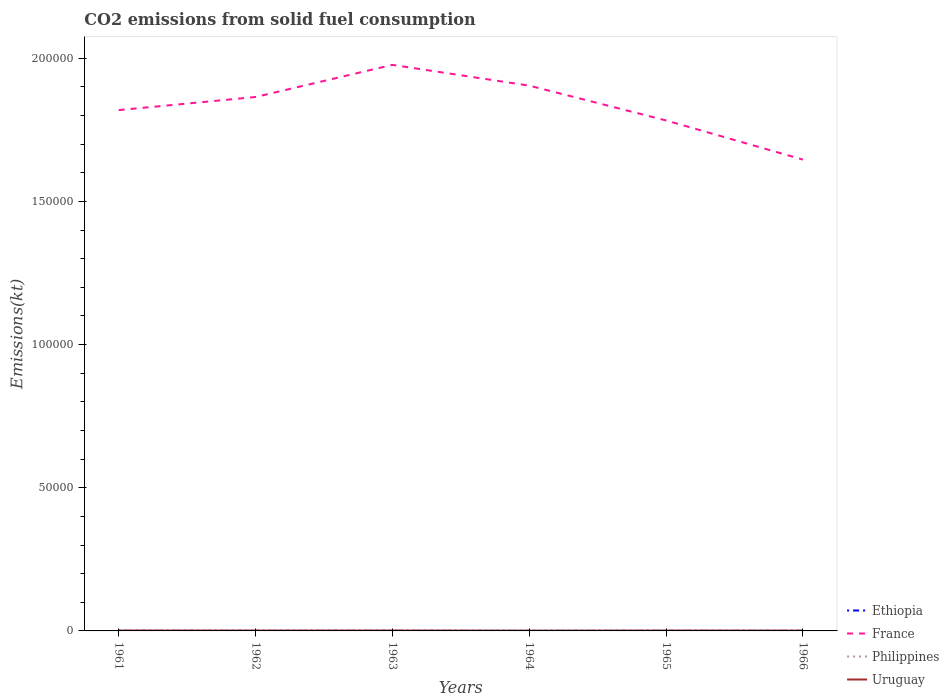How many different coloured lines are there?
Your answer should be compact. 4. Does the line corresponding to Philippines intersect with the line corresponding to France?
Your answer should be compact. No. Is the number of lines equal to the number of legend labels?
Provide a succinct answer. Yes. Across all years, what is the maximum amount of CO2 emitted in Uruguay?
Provide a succinct answer. 84.34. In which year was the amount of CO2 emitted in Ethiopia maximum?
Provide a succinct answer. 1964. What is the total amount of CO2 emitted in France in the graph?
Your answer should be compact. 1.22e+04. What is the difference between the highest and the second highest amount of CO2 emitted in France?
Offer a terse response. 3.31e+04. What is the difference between the highest and the lowest amount of CO2 emitted in Uruguay?
Make the answer very short. 4. Is the amount of CO2 emitted in Uruguay strictly greater than the amount of CO2 emitted in Ethiopia over the years?
Offer a terse response. No. How many years are there in the graph?
Offer a very short reply. 6. What is the difference between two consecutive major ticks on the Y-axis?
Offer a very short reply. 5.00e+04. Are the values on the major ticks of Y-axis written in scientific E-notation?
Offer a very short reply. No. Where does the legend appear in the graph?
Keep it short and to the point. Bottom right. How are the legend labels stacked?
Offer a very short reply. Vertical. What is the title of the graph?
Offer a terse response. CO2 emissions from solid fuel consumption. What is the label or title of the Y-axis?
Ensure brevity in your answer.  Emissions(kt). What is the Emissions(kt) of Ethiopia in 1961?
Give a very brief answer. 25.67. What is the Emissions(kt) of France in 1961?
Keep it short and to the point. 1.82e+05. What is the Emissions(kt) in Philippines in 1961?
Give a very brief answer. 179.68. What is the Emissions(kt) in Uruguay in 1961?
Provide a succinct answer. 124.68. What is the Emissions(kt) in Ethiopia in 1962?
Make the answer very short. 22. What is the Emissions(kt) of France in 1962?
Offer a terse response. 1.86e+05. What is the Emissions(kt) in Philippines in 1962?
Ensure brevity in your answer.  212.69. What is the Emissions(kt) of Uruguay in 1962?
Your answer should be very brief. 110.01. What is the Emissions(kt) of Ethiopia in 1963?
Your answer should be compact. 25.67. What is the Emissions(kt) in France in 1963?
Keep it short and to the point. 1.98e+05. What is the Emissions(kt) of Philippines in 1963?
Ensure brevity in your answer.  201.69. What is the Emissions(kt) in Uruguay in 1963?
Provide a short and direct response. 117.34. What is the Emissions(kt) in Ethiopia in 1964?
Keep it short and to the point. 3.67. What is the Emissions(kt) of France in 1964?
Make the answer very short. 1.90e+05. What is the Emissions(kt) of Philippines in 1964?
Give a very brief answer. 150.35. What is the Emissions(kt) of Uruguay in 1964?
Offer a terse response. 84.34. What is the Emissions(kt) of Ethiopia in 1965?
Provide a succinct answer. 25.67. What is the Emissions(kt) of France in 1965?
Give a very brief answer. 1.78e+05. What is the Emissions(kt) of Philippines in 1965?
Make the answer very short. 150.35. What is the Emissions(kt) in Uruguay in 1965?
Give a very brief answer. 110.01. What is the Emissions(kt) of Ethiopia in 1966?
Offer a very short reply. 25.67. What is the Emissions(kt) in France in 1966?
Your response must be concise. 1.65e+05. What is the Emissions(kt) of Philippines in 1966?
Keep it short and to the point. 135.68. What is the Emissions(kt) in Uruguay in 1966?
Your answer should be compact. 99.01. Across all years, what is the maximum Emissions(kt) of Ethiopia?
Your response must be concise. 25.67. Across all years, what is the maximum Emissions(kt) in France?
Keep it short and to the point. 1.98e+05. Across all years, what is the maximum Emissions(kt) of Philippines?
Keep it short and to the point. 212.69. Across all years, what is the maximum Emissions(kt) in Uruguay?
Offer a very short reply. 124.68. Across all years, what is the minimum Emissions(kt) of Ethiopia?
Your response must be concise. 3.67. Across all years, what is the minimum Emissions(kt) of France?
Provide a short and direct response. 1.65e+05. Across all years, what is the minimum Emissions(kt) in Philippines?
Offer a terse response. 135.68. Across all years, what is the minimum Emissions(kt) in Uruguay?
Provide a succinct answer. 84.34. What is the total Emissions(kt) of Ethiopia in the graph?
Provide a short and direct response. 128.34. What is the total Emissions(kt) of France in the graph?
Provide a succinct answer. 1.10e+06. What is the total Emissions(kt) of Philippines in the graph?
Give a very brief answer. 1030.43. What is the total Emissions(kt) in Uruguay in the graph?
Ensure brevity in your answer.  645.39. What is the difference between the Emissions(kt) in Ethiopia in 1961 and that in 1962?
Provide a succinct answer. 3.67. What is the difference between the Emissions(kt) in France in 1961 and that in 1962?
Offer a very short reply. -4583.75. What is the difference between the Emissions(kt) in Philippines in 1961 and that in 1962?
Your response must be concise. -33. What is the difference between the Emissions(kt) in Uruguay in 1961 and that in 1962?
Offer a terse response. 14.67. What is the difference between the Emissions(kt) in France in 1961 and that in 1963?
Offer a terse response. -1.58e+04. What is the difference between the Emissions(kt) of Philippines in 1961 and that in 1963?
Make the answer very short. -22. What is the difference between the Emissions(kt) of Uruguay in 1961 and that in 1963?
Your response must be concise. 7.33. What is the difference between the Emissions(kt) of Ethiopia in 1961 and that in 1964?
Offer a terse response. 22. What is the difference between the Emissions(kt) of France in 1961 and that in 1964?
Keep it short and to the point. -8551.44. What is the difference between the Emissions(kt) in Philippines in 1961 and that in 1964?
Provide a short and direct response. 29.34. What is the difference between the Emissions(kt) in Uruguay in 1961 and that in 1964?
Provide a succinct answer. 40.34. What is the difference between the Emissions(kt) of France in 1961 and that in 1965?
Keep it short and to the point. 3600.99. What is the difference between the Emissions(kt) in Philippines in 1961 and that in 1965?
Keep it short and to the point. 29.34. What is the difference between the Emissions(kt) in Uruguay in 1961 and that in 1965?
Offer a terse response. 14.67. What is the difference between the Emissions(kt) in Ethiopia in 1961 and that in 1966?
Your response must be concise. 0. What is the difference between the Emissions(kt) of France in 1961 and that in 1966?
Offer a terse response. 1.73e+04. What is the difference between the Emissions(kt) of Philippines in 1961 and that in 1966?
Keep it short and to the point. 44. What is the difference between the Emissions(kt) of Uruguay in 1961 and that in 1966?
Ensure brevity in your answer.  25.67. What is the difference between the Emissions(kt) in Ethiopia in 1962 and that in 1963?
Offer a terse response. -3.67. What is the difference between the Emissions(kt) of France in 1962 and that in 1963?
Offer a terse response. -1.12e+04. What is the difference between the Emissions(kt) in Philippines in 1962 and that in 1963?
Keep it short and to the point. 11. What is the difference between the Emissions(kt) of Uruguay in 1962 and that in 1963?
Keep it short and to the point. -7.33. What is the difference between the Emissions(kt) of Ethiopia in 1962 and that in 1964?
Keep it short and to the point. 18.34. What is the difference between the Emissions(kt) of France in 1962 and that in 1964?
Make the answer very short. -3967.69. What is the difference between the Emissions(kt) of Philippines in 1962 and that in 1964?
Provide a short and direct response. 62.34. What is the difference between the Emissions(kt) in Uruguay in 1962 and that in 1964?
Offer a terse response. 25.67. What is the difference between the Emissions(kt) of Ethiopia in 1962 and that in 1965?
Keep it short and to the point. -3.67. What is the difference between the Emissions(kt) in France in 1962 and that in 1965?
Give a very brief answer. 8184.74. What is the difference between the Emissions(kt) of Philippines in 1962 and that in 1965?
Keep it short and to the point. 62.34. What is the difference between the Emissions(kt) in Uruguay in 1962 and that in 1965?
Keep it short and to the point. 0. What is the difference between the Emissions(kt) in Ethiopia in 1962 and that in 1966?
Offer a very short reply. -3.67. What is the difference between the Emissions(kt) of France in 1962 and that in 1966?
Your answer should be compact. 2.19e+04. What is the difference between the Emissions(kt) of Philippines in 1962 and that in 1966?
Keep it short and to the point. 77.01. What is the difference between the Emissions(kt) of Uruguay in 1962 and that in 1966?
Your answer should be very brief. 11. What is the difference between the Emissions(kt) of Ethiopia in 1963 and that in 1964?
Your answer should be compact. 22. What is the difference between the Emissions(kt) in France in 1963 and that in 1964?
Offer a very short reply. 7249.66. What is the difference between the Emissions(kt) in Philippines in 1963 and that in 1964?
Ensure brevity in your answer.  51.34. What is the difference between the Emissions(kt) of Uruguay in 1963 and that in 1964?
Keep it short and to the point. 33. What is the difference between the Emissions(kt) in France in 1963 and that in 1965?
Your answer should be very brief. 1.94e+04. What is the difference between the Emissions(kt) in Philippines in 1963 and that in 1965?
Your answer should be very brief. 51.34. What is the difference between the Emissions(kt) in Uruguay in 1963 and that in 1965?
Your answer should be compact. 7.33. What is the difference between the Emissions(kt) in France in 1963 and that in 1966?
Provide a short and direct response. 3.31e+04. What is the difference between the Emissions(kt) of Philippines in 1963 and that in 1966?
Provide a succinct answer. 66.01. What is the difference between the Emissions(kt) of Uruguay in 1963 and that in 1966?
Provide a short and direct response. 18.34. What is the difference between the Emissions(kt) of Ethiopia in 1964 and that in 1965?
Offer a terse response. -22. What is the difference between the Emissions(kt) in France in 1964 and that in 1965?
Give a very brief answer. 1.22e+04. What is the difference between the Emissions(kt) of Philippines in 1964 and that in 1965?
Give a very brief answer. 0. What is the difference between the Emissions(kt) in Uruguay in 1964 and that in 1965?
Your answer should be very brief. -25.67. What is the difference between the Emissions(kt) in Ethiopia in 1964 and that in 1966?
Ensure brevity in your answer.  -22. What is the difference between the Emissions(kt) in France in 1964 and that in 1966?
Make the answer very short. 2.58e+04. What is the difference between the Emissions(kt) of Philippines in 1964 and that in 1966?
Provide a succinct answer. 14.67. What is the difference between the Emissions(kt) in Uruguay in 1964 and that in 1966?
Offer a very short reply. -14.67. What is the difference between the Emissions(kt) in Ethiopia in 1965 and that in 1966?
Offer a terse response. 0. What is the difference between the Emissions(kt) in France in 1965 and that in 1966?
Make the answer very short. 1.37e+04. What is the difference between the Emissions(kt) of Philippines in 1965 and that in 1966?
Your response must be concise. 14.67. What is the difference between the Emissions(kt) of Uruguay in 1965 and that in 1966?
Offer a terse response. 11. What is the difference between the Emissions(kt) in Ethiopia in 1961 and the Emissions(kt) in France in 1962?
Provide a short and direct response. -1.86e+05. What is the difference between the Emissions(kt) of Ethiopia in 1961 and the Emissions(kt) of Philippines in 1962?
Give a very brief answer. -187.02. What is the difference between the Emissions(kt) of Ethiopia in 1961 and the Emissions(kt) of Uruguay in 1962?
Provide a short and direct response. -84.34. What is the difference between the Emissions(kt) in France in 1961 and the Emissions(kt) in Philippines in 1962?
Ensure brevity in your answer.  1.82e+05. What is the difference between the Emissions(kt) of France in 1961 and the Emissions(kt) of Uruguay in 1962?
Keep it short and to the point. 1.82e+05. What is the difference between the Emissions(kt) in Philippines in 1961 and the Emissions(kt) in Uruguay in 1962?
Offer a terse response. 69.67. What is the difference between the Emissions(kt) in Ethiopia in 1961 and the Emissions(kt) in France in 1963?
Make the answer very short. -1.98e+05. What is the difference between the Emissions(kt) of Ethiopia in 1961 and the Emissions(kt) of Philippines in 1963?
Offer a terse response. -176.02. What is the difference between the Emissions(kt) in Ethiopia in 1961 and the Emissions(kt) in Uruguay in 1963?
Offer a very short reply. -91.67. What is the difference between the Emissions(kt) in France in 1961 and the Emissions(kt) in Philippines in 1963?
Keep it short and to the point. 1.82e+05. What is the difference between the Emissions(kt) of France in 1961 and the Emissions(kt) of Uruguay in 1963?
Ensure brevity in your answer.  1.82e+05. What is the difference between the Emissions(kt) of Philippines in 1961 and the Emissions(kt) of Uruguay in 1963?
Offer a terse response. 62.34. What is the difference between the Emissions(kt) in Ethiopia in 1961 and the Emissions(kt) in France in 1964?
Give a very brief answer. -1.90e+05. What is the difference between the Emissions(kt) of Ethiopia in 1961 and the Emissions(kt) of Philippines in 1964?
Your answer should be compact. -124.68. What is the difference between the Emissions(kt) in Ethiopia in 1961 and the Emissions(kt) in Uruguay in 1964?
Give a very brief answer. -58.67. What is the difference between the Emissions(kt) of France in 1961 and the Emissions(kt) of Philippines in 1964?
Offer a terse response. 1.82e+05. What is the difference between the Emissions(kt) in France in 1961 and the Emissions(kt) in Uruguay in 1964?
Make the answer very short. 1.82e+05. What is the difference between the Emissions(kt) in Philippines in 1961 and the Emissions(kt) in Uruguay in 1964?
Your response must be concise. 95.34. What is the difference between the Emissions(kt) in Ethiopia in 1961 and the Emissions(kt) in France in 1965?
Offer a very short reply. -1.78e+05. What is the difference between the Emissions(kt) of Ethiopia in 1961 and the Emissions(kt) of Philippines in 1965?
Offer a very short reply. -124.68. What is the difference between the Emissions(kt) of Ethiopia in 1961 and the Emissions(kt) of Uruguay in 1965?
Your answer should be very brief. -84.34. What is the difference between the Emissions(kt) of France in 1961 and the Emissions(kt) of Philippines in 1965?
Your answer should be very brief. 1.82e+05. What is the difference between the Emissions(kt) in France in 1961 and the Emissions(kt) in Uruguay in 1965?
Your answer should be compact. 1.82e+05. What is the difference between the Emissions(kt) in Philippines in 1961 and the Emissions(kt) in Uruguay in 1965?
Offer a very short reply. 69.67. What is the difference between the Emissions(kt) in Ethiopia in 1961 and the Emissions(kt) in France in 1966?
Provide a short and direct response. -1.65e+05. What is the difference between the Emissions(kt) of Ethiopia in 1961 and the Emissions(kt) of Philippines in 1966?
Keep it short and to the point. -110.01. What is the difference between the Emissions(kt) of Ethiopia in 1961 and the Emissions(kt) of Uruguay in 1966?
Your response must be concise. -73.34. What is the difference between the Emissions(kt) in France in 1961 and the Emissions(kt) in Philippines in 1966?
Keep it short and to the point. 1.82e+05. What is the difference between the Emissions(kt) in France in 1961 and the Emissions(kt) in Uruguay in 1966?
Provide a short and direct response. 1.82e+05. What is the difference between the Emissions(kt) of Philippines in 1961 and the Emissions(kt) of Uruguay in 1966?
Ensure brevity in your answer.  80.67. What is the difference between the Emissions(kt) of Ethiopia in 1962 and the Emissions(kt) of France in 1963?
Provide a short and direct response. -1.98e+05. What is the difference between the Emissions(kt) in Ethiopia in 1962 and the Emissions(kt) in Philippines in 1963?
Offer a terse response. -179.68. What is the difference between the Emissions(kt) of Ethiopia in 1962 and the Emissions(kt) of Uruguay in 1963?
Give a very brief answer. -95.34. What is the difference between the Emissions(kt) in France in 1962 and the Emissions(kt) in Philippines in 1963?
Provide a short and direct response. 1.86e+05. What is the difference between the Emissions(kt) of France in 1962 and the Emissions(kt) of Uruguay in 1963?
Your answer should be compact. 1.86e+05. What is the difference between the Emissions(kt) of Philippines in 1962 and the Emissions(kt) of Uruguay in 1963?
Offer a terse response. 95.34. What is the difference between the Emissions(kt) in Ethiopia in 1962 and the Emissions(kt) in France in 1964?
Make the answer very short. -1.90e+05. What is the difference between the Emissions(kt) in Ethiopia in 1962 and the Emissions(kt) in Philippines in 1964?
Keep it short and to the point. -128.34. What is the difference between the Emissions(kt) of Ethiopia in 1962 and the Emissions(kt) of Uruguay in 1964?
Offer a very short reply. -62.34. What is the difference between the Emissions(kt) of France in 1962 and the Emissions(kt) of Philippines in 1964?
Offer a very short reply. 1.86e+05. What is the difference between the Emissions(kt) in France in 1962 and the Emissions(kt) in Uruguay in 1964?
Provide a succinct answer. 1.86e+05. What is the difference between the Emissions(kt) in Philippines in 1962 and the Emissions(kt) in Uruguay in 1964?
Offer a very short reply. 128.34. What is the difference between the Emissions(kt) in Ethiopia in 1962 and the Emissions(kt) in France in 1965?
Your response must be concise. -1.78e+05. What is the difference between the Emissions(kt) of Ethiopia in 1962 and the Emissions(kt) of Philippines in 1965?
Your answer should be very brief. -128.34. What is the difference between the Emissions(kt) of Ethiopia in 1962 and the Emissions(kt) of Uruguay in 1965?
Provide a succinct answer. -88.01. What is the difference between the Emissions(kt) in France in 1962 and the Emissions(kt) in Philippines in 1965?
Keep it short and to the point. 1.86e+05. What is the difference between the Emissions(kt) of France in 1962 and the Emissions(kt) of Uruguay in 1965?
Provide a succinct answer. 1.86e+05. What is the difference between the Emissions(kt) in Philippines in 1962 and the Emissions(kt) in Uruguay in 1965?
Offer a terse response. 102.68. What is the difference between the Emissions(kt) of Ethiopia in 1962 and the Emissions(kt) of France in 1966?
Your response must be concise. -1.65e+05. What is the difference between the Emissions(kt) of Ethiopia in 1962 and the Emissions(kt) of Philippines in 1966?
Offer a terse response. -113.68. What is the difference between the Emissions(kt) in Ethiopia in 1962 and the Emissions(kt) in Uruguay in 1966?
Offer a very short reply. -77.01. What is the difference between the Emissions(kt) of France in 1962 and the Emissions(kt) of Philippines in 1966?
Ensure brevity in your answer.  1.86e+05. What is the difference between the Emissions(kt) of France in 1962 and the Emissions(kt) of Uruguay in 1966?
Make the answer very short. 1.86e+05. What is the difference between the Emissions(kt) in Philippines in 1962 and the Emissions(kt) in Uruguay in 1966?
Provide a succinct answer. 113.68. What is the difference between the Emissions(kt) in Ethiopia in 1963 and the Emissions(kt) in France in 1964?
Your response must be concise. -1.90e+05. What is the difference between the Emissions(kt) of Ethiopia in 1963 and the Emissions(kt) of Philippines in 1964?
Give a very brief answer. -124.68. What is the difference between the Emissions(kt) in Ethiopia in 1963 and the Emissions(kt) in Uruguay in 1964?
Your answer should be compact. -58.67. What is the difference between the Emissions(kt) in France in 1963 and the Emissions(kt) in Philippines in 1964?
Ensure brevity in your answer.  1.98e+05. What is the difference between the Emissions(kt) of France in 1963 and the Emissions(kt) of Uruguay in 1964?
Offer a terse response. 1.98e+05. What is the difference between the Emissions(kt) of Philippines in 1963 and the Emissions(kt) of Uruguay in 1964?
Your answer should be compact. 117.34. What is the difference between the Emissions(kt) in Ethiopia in 1963 and the Emissions(kt) in France in 1965?
Your answer should be compact. -1.78e+05. What is the difference between the Emissions(kt) of Ethiopia in 1963 and the Emissions(kt) of Philippines in 1965?
Your response must be concise. -124.68. What is the difference between the Emissions(kt) of Ethiopia in 1963 and the Emissions(kt) of Uruguay in 1965?
Ensure brevity in your answer.  -84.34. What is the difference between the Emissions(kt) of France in 1963 and the Emissions(kt) of Philippines in 1965?
Provide a succinct answer. 1.98e+05. What is the difference between the Emissions(kt) of France in 1963 and the Emissions(kt) of Uruguay in 1965?
Make the answer very short. 1.98e+05. What is the difference between the Emissions(kt) in Philippines in 1963 and the Emissions(kt) in Uruguay in 1965?
Your answer should be compact. 91.67. What is the difference between the Emissions(kt) of Ethiopia in 1963 and the Emissions(kt) of France in 1966?
Your response must be concise. -1.65e+05. What is the difference between the Emissions(kt) in Ethiopia in 1963 and the Emissions(kt) in Philippines in 1966?
Make the answer very short. -110.01. What is the difference between the Emissions(kt) of Ethiopia in 1963 and the Emissions(kt) of Uruguay in 1966?
Make the answer very short. -73.34. What is the difference between the Emissions(kt) of France in 1963 and the Emissions(kt) of Philippines in 1966?
Give a very brief answer. 1.98e+05. What is the difference between the Emissions(kt) of France in 1963 and the Emissions(kt) of Uruguay in 1966?
Make the answer very short. 1.98e+05. What is the difference between the Emissions(kt) of Philippines in 1963 and the Emissions(kt) of Uruguay in 1966?
Make the answer very short. 102.68. What is the difference between the Emissions(kt) of Ethiopia in 1964 and the Emissions(kt) of France in 1965?
Your answer should be compact. -1.78e+05. What is the difference between the Emissions(kt) of Ethiopia in 1964 and the Emissions(kt) of Philippines in 1965?
Your response must be concise. -146.68. What is the difference between the Emissions(kt) of Ethiopia in 1964 and the Emissions(kt) of Uruguay in 1965?
Give a very brief answer. -106.34. What is the difference between the Emissions(kt) of France in 1964 and the Emissions(kt) of Philippines in 1965?
Provide a short and direct response. 1.90e+05. What is the difference between the Emissions(kt) of France in 1964 and the Emissions(kt) of Uruguay in 1965?
Provide a short and direct response. 1.90e+05. What is the difference between the Emissions(kt) in Philippines in 1964 and the Emissions(kt) in Uruguay in 1965?
Your answer should be compact. 40.34. What is the difference between the Emissions(kt) in Ethiopia in 1964 and the Emissions(kt) in France in 1966?
Make the answer very short. -1.65e+05. What is the difference between the Emissions(kt) of Ethiopia in 1964 and the Emissions(kt) of Philippines in 1966?
Give a very brief answer. -132.01. What is the difference between the Emissions(kt) of Ethiopia in 1964 and the Emissions(kt) of Uruguay in 1966?
Your answer should be very brief. -95.34. What is the difference between the Emissions(kt) of France in 1964 and the Emissions(kt) of Philippines in 1966?
Keep it short and to the point. 1.90e+05. What is the difference between the Emissions(kt) in France in 1964 and the Emissions(kt) in Uruguay in 1966?
Provide a succinct answer. 1.90e+05. What is the difference between the Emissions(kt) in Philippines in 1964 and the Emissions(kt) in Uruguay in 1966?
Your answer should be very brief. 51.34. What is the difference between the Emissions(kt) in Ethiopia in 1965 and the Emissions(kt) in France in 1966?
Provide a short and direct response. -1.65e+05. What is the difference between the Emissions(kt) of Ethiopia in 1965 and the Emissions(kt) of Philippines in 1966?
Offer a very short reply. -110.01. What is the difference between the Emissions(kt) of Ethiopia in 1965 and the Emissions(kt) of Uruguay in 1966?
Offer a very short reply. -73.34. What is the difference between the Emissions(kt) of France in 1965 and the Emissions(kt) of Philippines in 1966?
Offer a terse response. 1.78e+05. What is the difference between the Emissions(kt) of France in 1965 and the Emissions(kt) of Uruguay in 1966?
Your response must be concise. 1.78e+05. What is the difference between the Emissions(kt) of Philippines in 1965 and the Emissions(kt) of Uruguay in 1966?
Ensure brevity in your answer.  51.34. What is the average Emissions(kt) of Ethiopia per year?
Provide a short and direct response. 21.39. What is the average Emissions(kt) in France per year?
Give a very brief answer. 1.83e+05. What is the average Emissions(kt) in Philippines per year?
Your answer should be very brief. 171.74. What is the average Emissions(kt) of Uruguay per year?
Your answer should be very brief. 107.57. In the year 1961, what is the difference between the Emissions(kt) in Ethiopia and Emissions(kt) in France?
Keep it short and to the point. -1.82e+05. In the year 1961, what is the difference between the Emissions(kt) of Ethiopia and Emissions(kt) of Philippines?
Your answer should be compact. -154.01. In the year 1961, what is the difference between the Emissions(kt) in Ethiopia and Emissions(kt) in Uruguay?
Keep it short and to the point. -99.01. In the year 1961, what is the difference between the Emissions(kt) in France and Emissions(kt) in Philippines?
Offer a very short reply. 1.82e+05. In the year 1961, what is the difference between the Emissions(kt) of France and Emissions(kt) of Uruguay?
Provide a succinct answer. 1.82e+05. In the year 1961, what is the difference between the Emissions(kt) in Philippines and Emissions(kt) in Uruguay?
Make the answer very short. 55.01. In the year 1962, what is the difference between the Emissions(kt) in Ethiopia and Emissions(kt) in France?
Your answer should be compact. -1.86e+05. In the year 1962, what is the difference between the Emissions(kt) of Ethiopia and Emissions(kt) of Philippines?
Provide a short and direct response. -190.68. In the year 1962, what is the difference between the Emissions(kt) of Ethiopia and Emissions(kt) of Uruguay?
Your response must be concise. -88.01. In the year 1962, what is the difference between the Emissions(kt) of France and Emissions(kt) of Philippines?
Give a very brief answer. 1.86e+05. In the year 1962, what is the difference between the Emissions(kt) in France and Emissions(kt) in Uruguay?
Keep it short and to the point. 1.86e+05. In the year 1962, what is the difference between the Emissions(kt) in Philippines and Emissions(kt) in Uruguay?
Make the answer very short. 102.68. In the year 1963, what is the difference between the Emissions(kt) of Ethiopia and Emissions(kt) of France?
Your answer should be very brief. -1.98e+05. In the year 1963, what is the difference between the Emissions(kt) in Ethiopia and Emissions(kt) in Philippines?
Make the answer very short. -176.02. In the year 1963, what is the difference between the Emissions(kt) in Ethiopia and Emissions(kt) in Uruguay?
Give a very brief answer. -91.67. In the year 1963, what is the difference between the Emissions(kt) in France and Emissions(kt) in Philippines?
Your answer should be very brief. 1.97e+05. In the year 1963, what is the difference between the Emissions(kt) of France and Emissions(kt) of Uruguay?
Your answer should be very brief. 1.98e+05. In the year 1963, what is the difference between the Emissions(kt) of Philippines and Emissions(kt) of Uruguay?
Your answer should be compact. 84.34. In the year 1964, what is the difference between the Emissions(kt) of Ethiopia and Emissions(kt) of France?
Offer a very short reply. -1.90e+05. In the year 1964, what is the difference between the Emissions(kt) of Ethiopia and Emissions(kt) of Philippines?
Offer a very short reply. -146.68. In the year 1964, what is the difference between the Emissions(kt) of Ethiopia and Emissions(kt) of Uruguay?
Offer a terse response. -80.67. In the year 1964, what is the difference between the Emissions(kt) in France and Emissions(kt) in Philippines?
Offer a terse response. 1.90e+05. In the year 1964, what is the difference between the Emissions(kt) in France and Emissions(kt) in Uruguay?
Make the answer very short. 1.90e+05. In the year 1964, what is the difference between the Emissions(kt) of Philippines and Emissions(kt) of Uruguay?
Offer a terse response. 66.01. In the year 1965, what is the difference between the Emissions(kt) in Ethiopia and Emissions(kt) in France?
Provide a succinct answer. -1.78e+05. In the year 1965, what is the difference between the Emissions(kt) in Ethiopia and Emissions(kt) in Philippines?
Your response must be concise. -124.68. In the year 1965, what is the difference between the Emissions(kt) in Ethiopia and Emissions(kt) in Uruguay?
Keep it short and to the point. -84.34. In the year 1965, what is the difference between the Emissions(kt) of France and Emissions(kt) of Philippines?
Provide a succinct answer. 1.78e+05. In the year 1965, what is the difference between the Emissions(kt) of France and Emissions(kt) of Uruguay?
Keep it short and to the point. 1.78e+05. In the year 1965, what is the difference between the Emissions(kt) in Philippines and Emissions(kt) in Uruguay?
Your response must be concise. 40.34. In the year 1966, what is the difference between the Emissions(kt) of Ethiopia and Emissions(kt) of France?
Offer a very short reply. -1.65e+05. In the year 1966, what is the difference between the Emissions(kt) of Ethiopia and Emissions(kt) of Philippines?
Offer a terse response. -110.01. In the year 1966, what is the difference between the Emissions(kt) in Ethiopia and Emissions(kt) in Uruguay?
Your answer should be very brief. -73.34. In the year 1966, what is the difference between the Emissions(kt) in France and Emissions(kt) in Philippines?
Provide a succinct answer. 1.64e+05. In the year 1966, what is the difference between the Emissions(kt) in France and Emissions(kt) in Uruguay?
Give a very brief answer. 1.65e+05. In the year 1966, what is the difference between the Emissions(kt) of Philippines and Emissions(kt) of Uruguay?
Your response must be concise. 36.67. What is the ratio of the Emissions(kt) in France in 1961 to that in 1962?
Ensure brevity in your answer.  0.98. What is the ratio of the Emissions(kt) in Philippines in 1961 to that in 1962?
Make the answer very short. 0.84. What is the ratio of the Emissions(kt) of Uruguay in 1961 to that in 1962?
Give a very brief answer. 1.13. What is the ratio of the Emissions(kt) of Ethiopia in 1961 to that in 1963?
Offer a terse response. 1. What is the ratio of the Emissions(kt) of France in 1961 to that in 1963?
Your answer should be compact. 0.92. What is the ratio of the Emissions(kt) in Philippines in 1961 to that in 1963?
Your answer should be compact. 0.89. What is the ratio of the Emissions(kt) of Ethiopia in 1961 to that in 1964?
Your answer should be compact. 7. What is the ratio of the Emissions(kt) of France in 1961 to that in 1964?
Provide a succinct answer. 0.96. What is the ratio of the Emissions(kt) of Philippines in 1961 to that in 1964?
Provide a short and direct response. 1.2. What is the ratio of the Emissions(kt) of Uruguay in 1961 to that in 1964?
Offer a terse response. 1.48. What is the ratio of the Emissions(kt) of Ethiopia in 1961 to that in 1965?
Your response must be concise. 1. What is the ratio of the Emissions(kt) in France in 1961 to that in 1965?
Offer a very short reply. 1.02. What is the ratio of the Emissions(kt) in Philippines in 1961 to that in 1965?
Provide a short and direct response. 1.2. What is the ratio of the Emissions(kt) of Uruguay in 1961 to that in 1965?
Offer a very short reply. 1.13. What is the ratio of the Emissions(kt) in France in 1961 to that in 1966?
Your answer should be very brief. 1.1. What is the ratio of the Emissions(kt) of Philippines in 1961 to that in 1966?
Your response must be concise. 1.32. What is the ratio of the Emissions(kt) in Uruguay in 1961 to that in 1966?
Your answer should be very brief. 1.26. What is the ratio of the Emissions(kt) in Ethiopia in 1962 to that in 1963?
Your answer should be compact. 0.86. What is the ratio of the Emissions(kt) of France in 1962 to that in 1963?
Your answer should be compact. 0.94. What is the ratio of the Emissions(kt) of Philippines in 1962 to that in 1963?
Provide a short and direct response. 1.05. What is the ratio of the Emissions(kt) in Uruguay in 1962 to that in 1963?
Provide a short and direct response. 0.94. What is the ratio of the Emissions(kt) of France in 1962 to that in 1964?
Your response must be concise. 0.98. What is the ratio of the Emissions(kt) of Philippines in 1962 to that in 1964?
Offer a very short reply. 1.41. What is the ratio of the Emissions(kt) in Uruguay in 1962 to that in 1964?
Provide a succinct answer. 1.3. What is the ratio of the Emissions(kt) in Ethiopia in 1962 to that in 1965?
Offer a terse response. 0.86. What is the ratio of the Emissions(kt) in France in 1962 to that in 1965?
Offer a terse response. 1.05. What is the ratio of the Emissions(kt) in Philippines in 1962 to that in 1965?
Keep it short and to the point. 1.41. What is the ratio of the Emissions(kt) in Uruguay in 1962 to that in 1965?
Provide a succinct answer. 1. What is the ratio of the Emissions(kt) in France in 1962 to that in 1966?
Offer a very short reply. 1.13. What is the ratio of the Emissions(kt) in Philippines in 1962 to that in 1966?
Provide a short and direct response. 1.57. What is the ratio of the Emissions(kt) of Ethiopia in 1963 to that in 1964?
Ensure brevity in your answer.  7. What is the ratio of the Emissions(kt) of France in 1963 to that in 1964?
Your answer should be very brief. 1.04. What is the ratio of the Emissions(kt) in Philippines in 1963 to that in 1964?
Provide a short and direct response. 1.34. What is the ratio of the Emissions(kt) of Uruguay in 1963 to that in 1964?
Give a very brief answer. 1.39. What is the ratio of the Emissions(kt) in France in 1963 to that in 1965?
Make the answer very short. 1.11. What is the ratio of the Emissions(kt) of Philippines in 1963 to that in 1965?
Provide a succinct answer. 1.34. What is the ratio of the Emissions(kt) in Uruguay in 1963 to that in 1965?
Offer a very short reply. 1.07. What is the ratio of the Emissions(kt) of Ethiopia in 1963 to that in 1966?
Offer a very short reply. 1. What is the ratio of the Emissions(kt) of France in 1963 to that in 1966?
Your answer should be compact. 1.2. What is the ratio of the Emissions(kt) of Philippines in 1963 to that in 1966?
Provide a short and direct response. 1.49. What is the ratio of the Emissions(kt) of Uruguay in 1963 to that in 1966?
Provide a succinct answer. 1.19. What is the ratio of the Emissions(kt) of Ethiopia in 1964 to that in 1965?
Your answer should be compact. 0.14. What is the ratio of the Emissions(kt) of France in 1964 to that in 1965?
Keep it short and to the point. 1.07. What is the ratio of the Emissions(kt) in Philippines in 1964 to that in 1965?
Ensure brevity in your answer.  1. What is the ratio of the Emissions(kt) in Uruguay in 1964 to that in 1965?
Give a very brief answer. 0.77. What is the ratio of the Emissions(kt) in Ethiopia in 1964 to that in 1966?
Your answer should be very brief. 0.14. What is the ratio of the Emissions(kt) in France in 1964 to that in 1966?
Ensure brevity in your answer.  1.16. What is the ratio of the Emissions(kt) in Philippines in 1964 to that in 1966?
Provide a short and direct response. 1.11. What is the ratio of the Emissions(kt) of Uruguay in 1964 to that in 1966?
Ensure brevity in your answer.  0.85. What is the ratio of the Emissions(kt) in Ethiopia in 1965 to that in 1966?
Ensure brevity in your answer.  1. What is the ratio of the Emissions(kt) of France in 1965 to that in 1966?
Your answer should be very brief. 1.08. What is the ratio of the Emissions(kt) in Philippines in 1965 to that in 1966?
Ensure brevity in your answer.  1.11. What is the difference between the highest and the second highest Emissions(kt) of France?
Provide a succinct answer. 7249.66. What is the difference between the highest and the second highest Emissions(kt) in Philippines?
Your answer should be compact. 11. What is the difference between the highest and the second highest Emissions(kt) in Uruguay?
Ensure brevity in your answer.  7.33. What is the difference between the highest and the lowest Emissions(kt) of Ethiopia?
Ensure brevity in your answer.  22. What is the difference between the highest and the lowest Emissions(kt) in France?
Your answer should be compact. 3.31e+04. What is the difference between the highest and the lowest Emissions(kt) of Philippines?
Give a very brief answer. 77.01. What is the difference between the highest and the lowest Emissions(kt) of Uruguay?
Offer a very short reply. 40.34. 